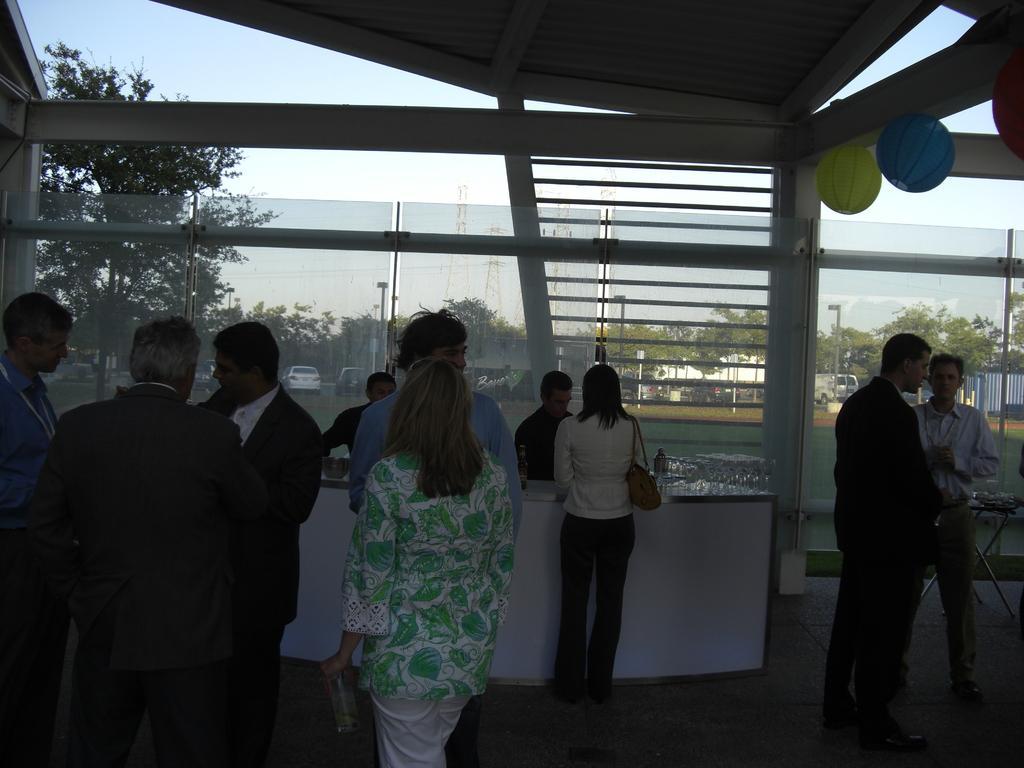Please provide a concise description of this image. The picture is taken in a building. In the foreground of the picture there are people, desk, glasses, table and other objects. At the top there are decorative items. In the center of the picture there is a glass window, outside the window there are vehicles, trees, street light, fencing, grass and other objects. 